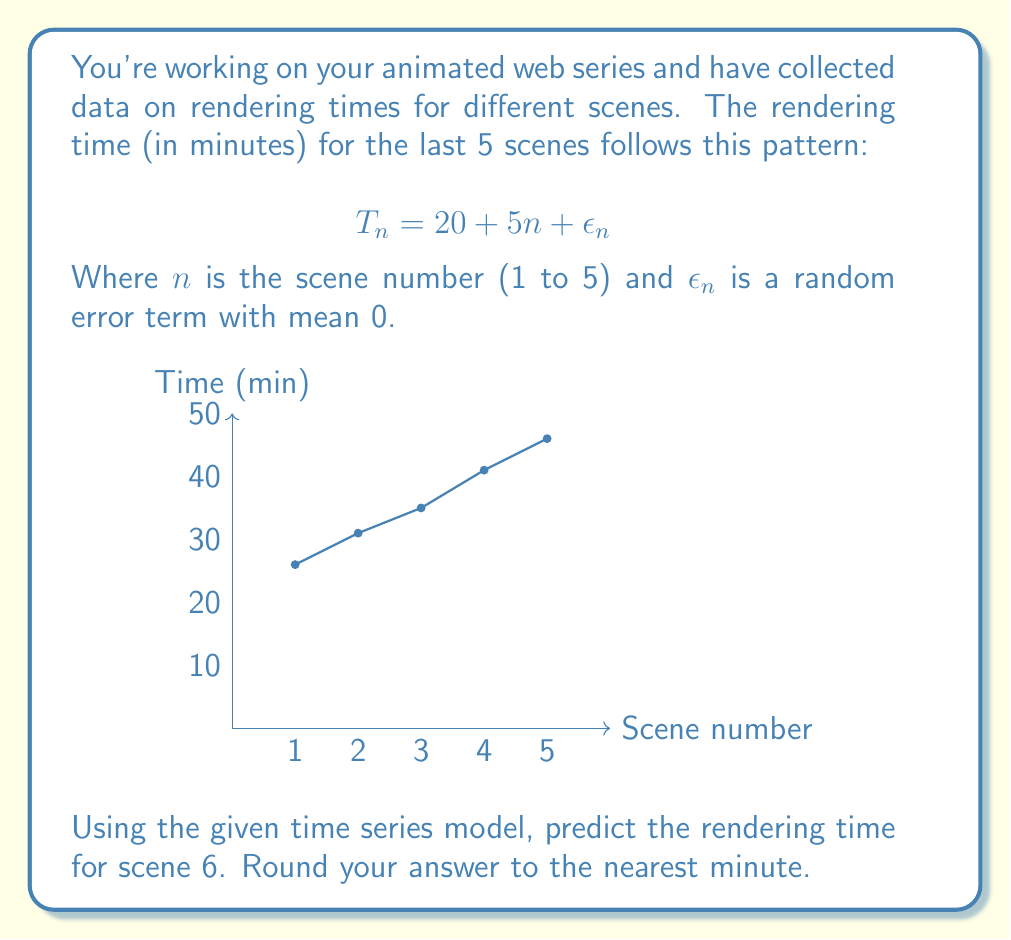Can you answer this question? Let's approach this step-by-step:

1) The time series model is given as:

   $$T_n = 20 + 5n + \epsilon_n$$

2) We're asked to predict for scene 6, so $n = 6$.

3) The $\epsilon_n$ term is a random error with mean 0. For prediction purposes, we typically set this to its expected value, which is 0.

4) Let's substitute these values into our equation:

   $$T_6 = 20 + 5(6) + 0$$

5) Now let's calculate:

   $$T_6 = 20 + 30 = 50$$

6) The question asks to round to the nearest minute, but 50 is already a whole number, so no rounding is necessary.

Therefore, the predicted rendering time for scene 6 is 50 minutes.
Answer: 50 minutes 